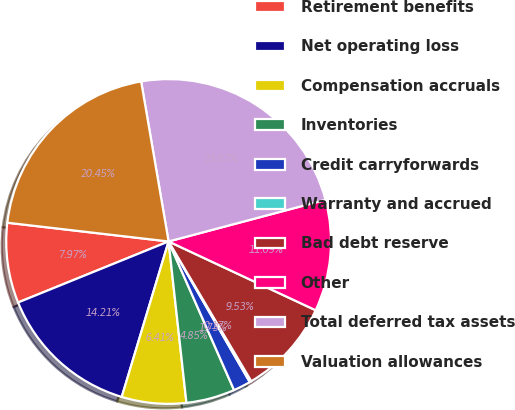Convert chart. <chart><loc_0><loc_0><loc_500><loc_500><pie_chart><fcel>Retirement benefits<fcel>Net operating loss<fcel>Compensation accruals<fcel>Inventories<fcel>Credit carryforwards<fcel>Warranty and accrued<fcel>Bad debt reserve<fcel>Other<fcel>Total deferred tax assets<fcel>Valuation allowances<nl><fcel>7.97%<fcel>14.21%<fcel>6.41%<fcel>4.85%<fcel>1.73%<fcel>0.17%<fcel>9.53%<fcel>11.09%<fcel>23.57%<fcel>20.45%<nl></chart> 